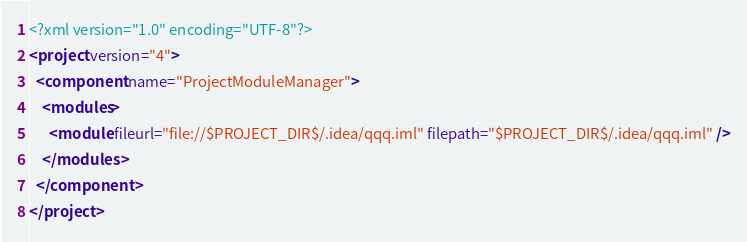Convert code to text. <code><loc_0><loc_0><loc_500><loc_500><_XML_><?xml version="1.0" encoding="UTF-8"?>
<project version="4">
  <component name="ProjectModuleManager">
    <modules>
      <module fileurl="file://$PROJECT_DIR$/.idea/qqq.iml" filepath="$PROJECT_DIR$/.idea/qqq.iml" />
    </modules>
  </component>
</project></code> 